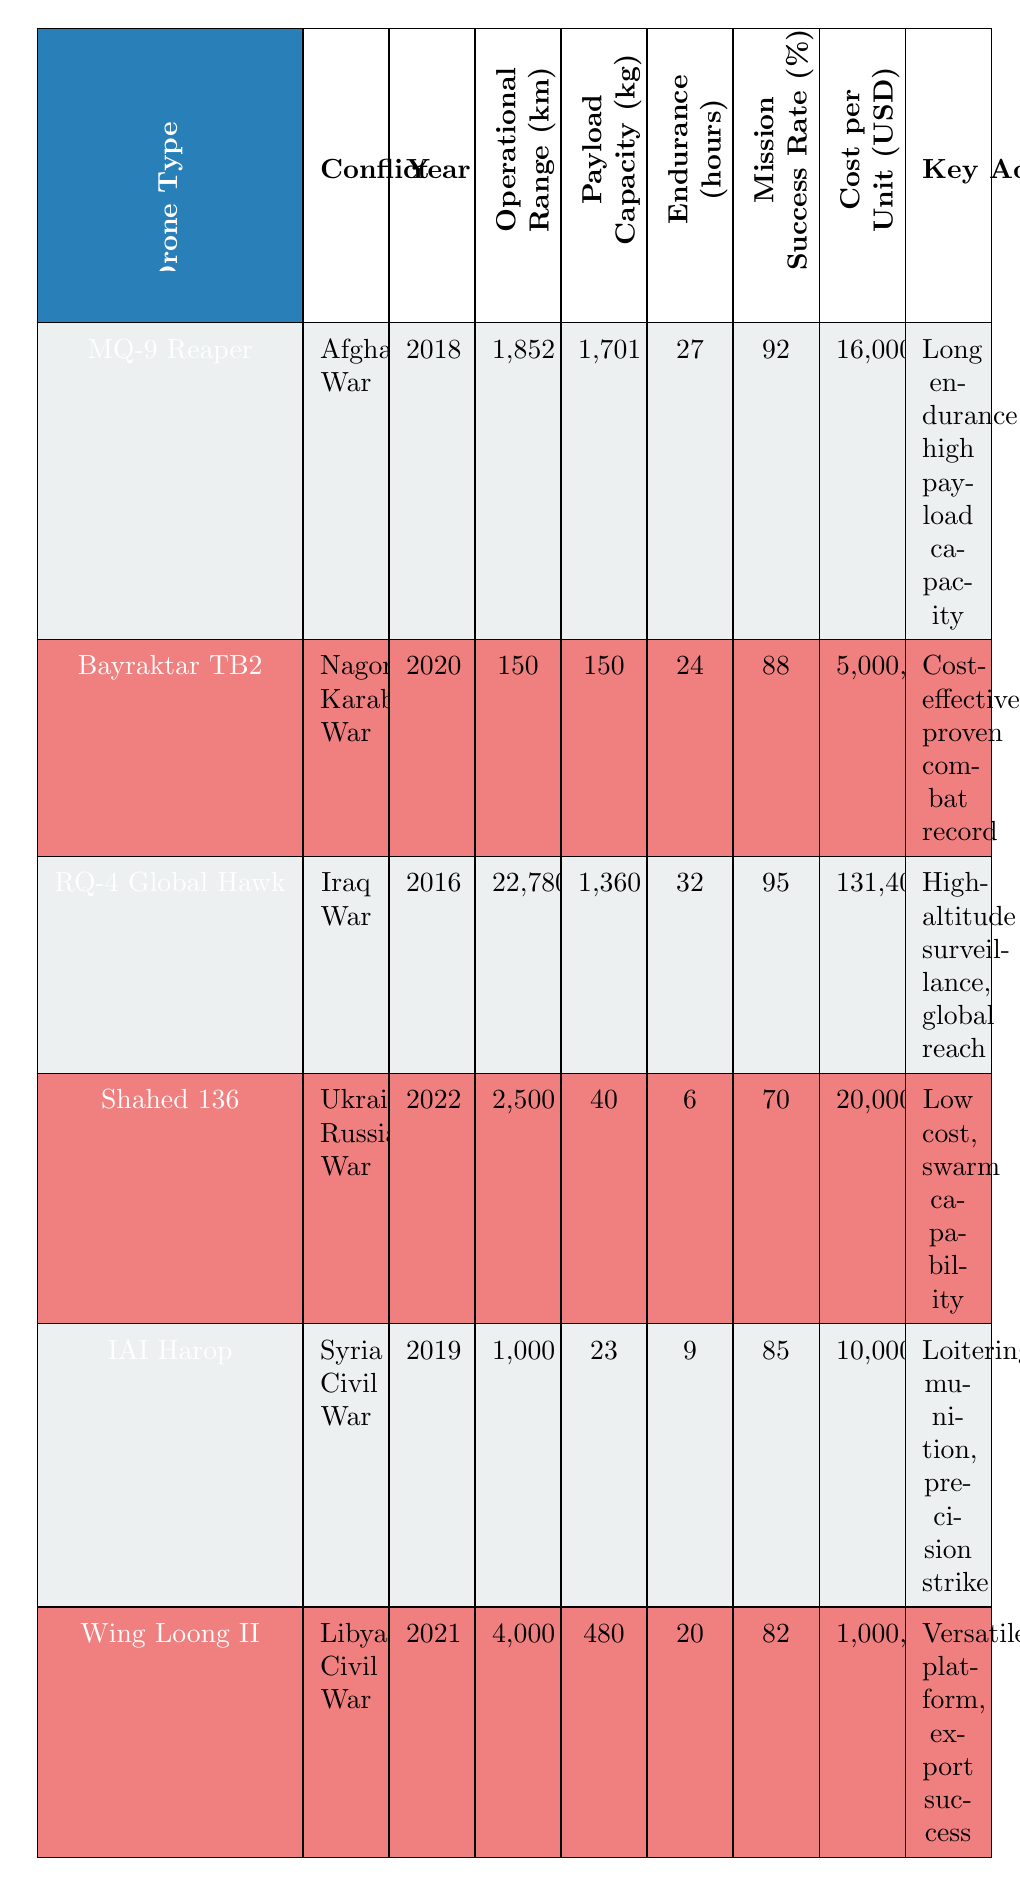What is the payload capacity of the MQ-9 Reaper? The payload capacity of the MQ-9 Reaper is listed in the table as 1701 kg.
Answer: 1701 kg Which drone has the highest mission success rate? The RQ-4 Global Hawk has the highest mission success rate in the table at 95%.
Answer: 95% What is the average operational range of the drones listed? The operational ranges are 1852 km, 150 km, 22780 km, 2500 km, 1000 km, and 4000 km. Adding these gives 30582 km. Dividing by the number of drones (6), the average operational range is 5097 km.
Answer: 5097 km Is the Bayraktar TB2 more cost-effective than the IAI Harop? Yes, the Bayraktar TB2 costs 5,000,000 USD, while the IAI Harop costs 10,000,000 USD, making the Bayraktar TB2 more cost-effective.
Answer: Yes Which drones have an endurance of more than 20 hours, and what are their mission success rates? The MQ-9 Reaper has 27 hours with a success rate of 92%, and the RQ-4 Global Hawk has 32 hours with a success rate of 95%.
Answer: MQ-9 Reaper: 92%, RQ-4 Global Hawk: 95% What is the difference in payload capacity between the Shahed 136 and the Bayraktar TB2? The payload capacity of the Shahed 136 is 40 kg while that of the Bayraktar TB2 is 150 kg. The difference is 150 kg - 40 kg = 110 kg.
Answer: 110 kg Which drone has the lowest cost per unit, and what is that cost? The Wing Loong II has the lowest cost per unit at 1,000,000 USD.
Answer: 1,000,000 USD Were there any drones used in the Ukraine-Russia War with a mission success rate lower than 80%? Yes, the Shahed 136 was used in the Ukraine-Russia War with a mission success rate of 70%, which is lower than 80%.
Answer: Yes What is the total cost if one unit of each drone type is purchased? The costs per unit are 16,000,000, 5,000,000, 131,400,000, 20,000, 10,000,000, and 1,000,000 USD. Adding these gives a total of 162,430,000 USD.
Answer: 162,430,000 USD 